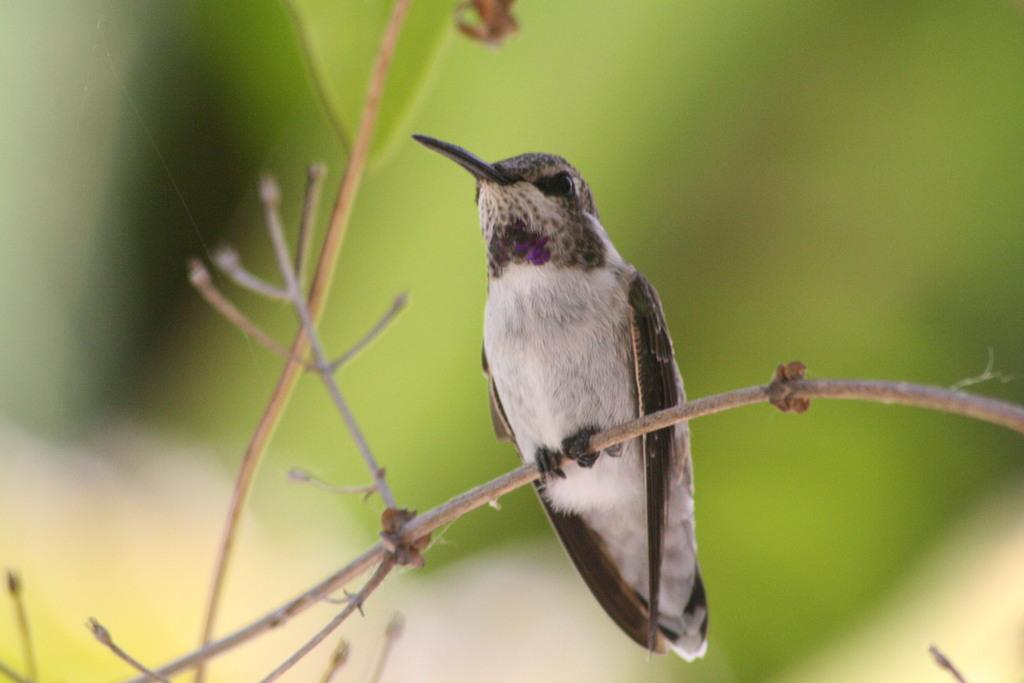What type of animal is present in the image? There is a bird in the image. Where is the bird located? The bird is on a plant stem. Can you describe the background of the image? The background of the image is blurred, and the background color is green. What type of shirt is the bird wearing in the image? There is no shirt present in the image, as birds do not wear clothing. 